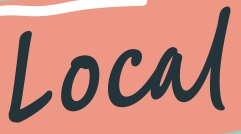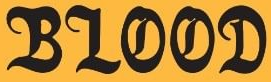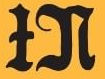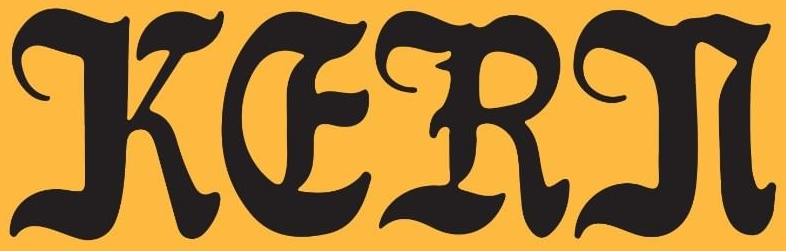Transcribe the words shown in these images in order, separated by a semicolon. Local; BLOOD; IN; KERN 